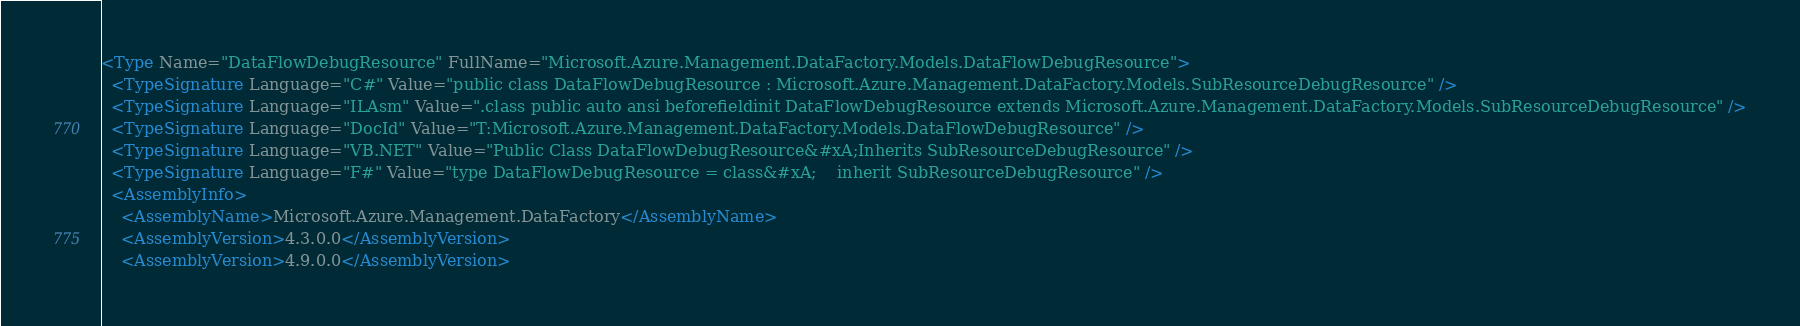<code> <loc_0><loc_0><loc_500><loc_500><_XML_><Type Name="DataFlowDebugResource" FullName="Microsoft.Azure.Management.DataFactory.Models.DataFlowDebugResource">
  <TypeSignature Language="C#" Value="public class DataFlowDebugResource : Microsoft.Azure.Management.DataFactory.Models.SubResourceDebugResource" />
  <TypeSignature Language="ILAsm" Value=".class public auto ansi beforefieldinit DataFlowDebugResource extends Microsoft.Azure.Management.DataFactory.Models.SubResourceDebugResource" />
  <TypeSignature Language="DocId" Value="T:Microsoft.Azure.Management.DataFactory.Models.DataFlowDebugResource" />
  <TypeSignature Language="VB.NET" Value="Public Class DataFlowDebugResource&#xA;Inherits SubResourceDebugResource" />
  <TypeSignature Language="F#" Value="type DataFlowDebugResource = class&#xA;    inherit SubResourceDebugResource" />
  <AssemblyInfo>
    <AssemblyName>Microsoft.Azure.Management.DataFactory</AssemblyName>
    <AssemblyVersion>4.3.0.0</AssemblyVersion>
    <AssemblyVersion>4.9.0.0</AssemblyVersion></code> 